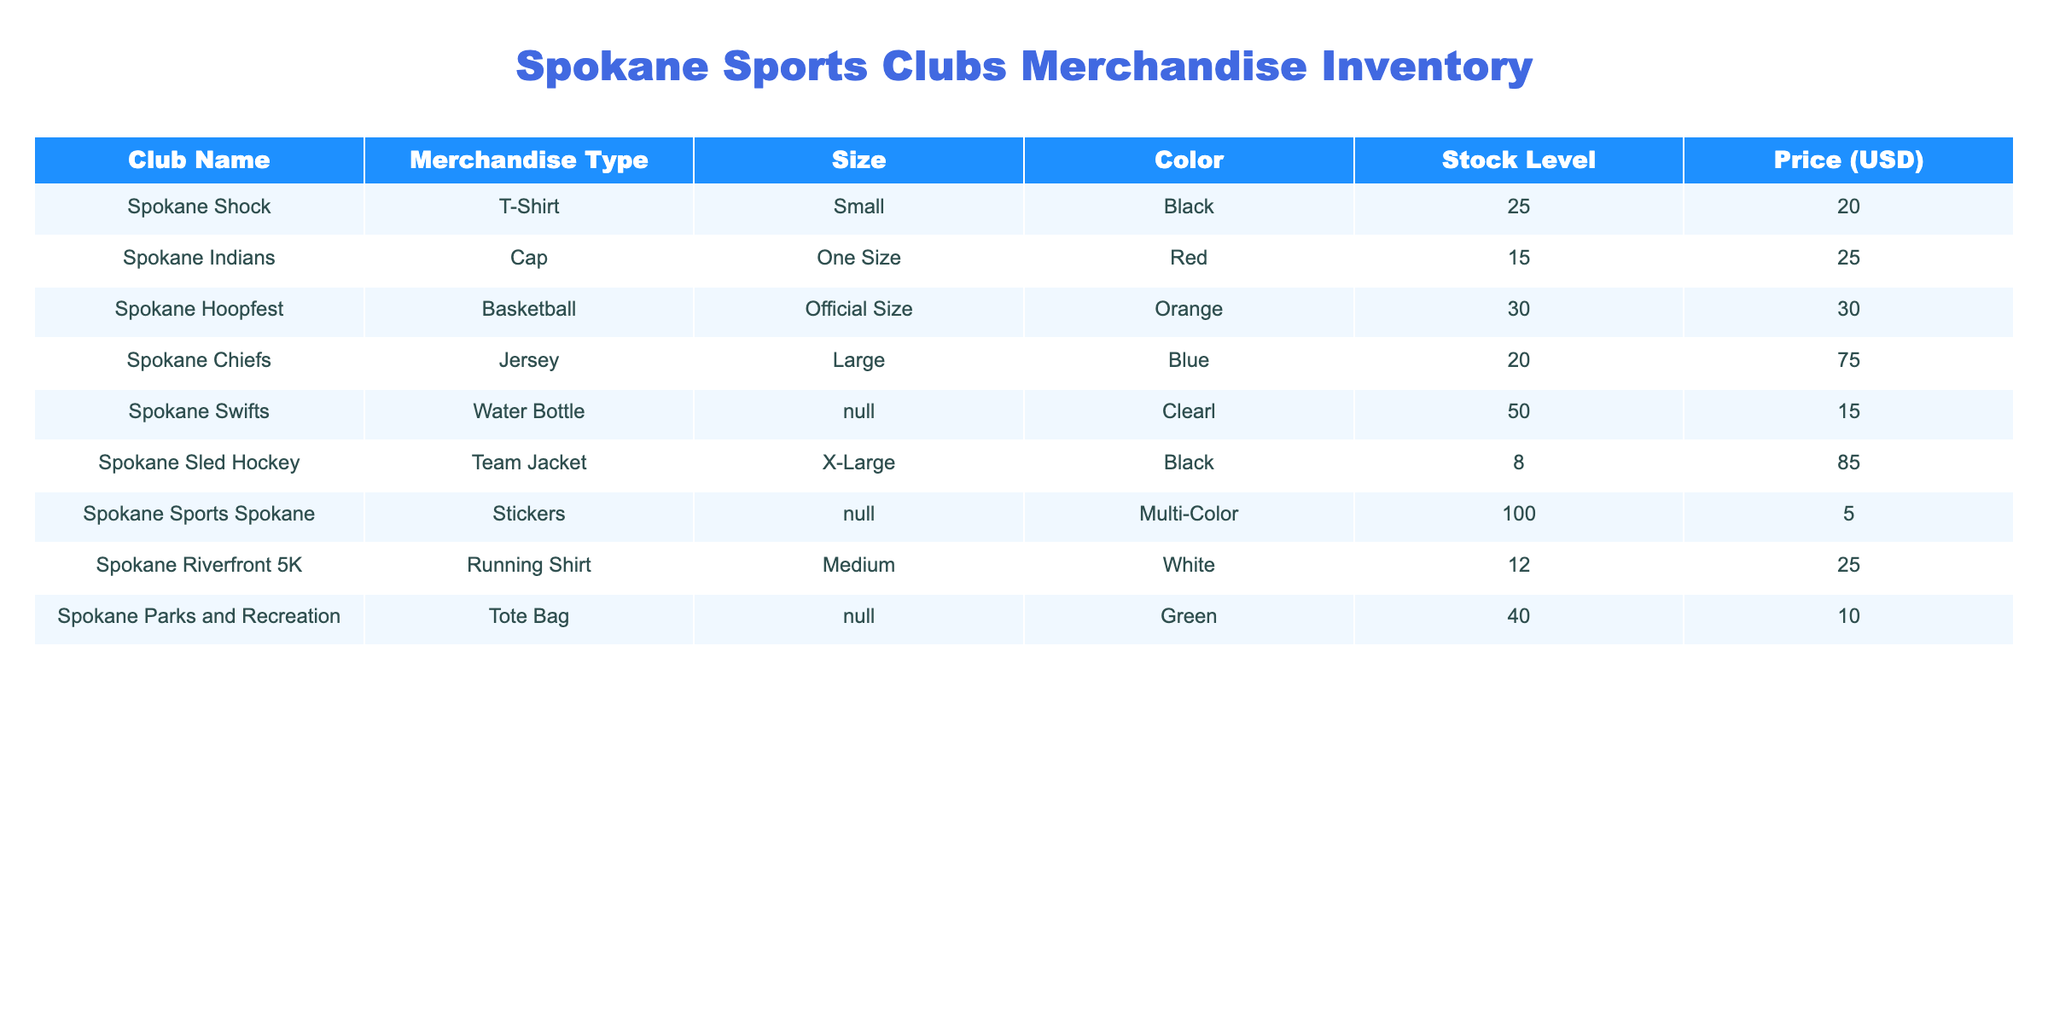What is the stock level of Spokane Shock T-Shirts? The table lists the merchandise inventory, and under the Spokane Shock row, the stock level is indicated as 25.
Answer: 25 How many items of stock are available for Spokane Chiefs Jerseys? The inventory for Spokane Chiefs Jerseys is listed as 20 units in the table.
Answer: 20 Which merchandise type has the highest stock level? By comparing the stock levels in the table, Spokane Sports Spokane has the highest stock level at 100.
Answer: Stickers Is there any merchandise that costs less than $15? Reviewing the price column, Spokane Sports Spokane Stickers at 5 USD is the only item priced below 15 USD.
Answer: Yes What is the total stock level of all merchandise types combined? Summing the stock levels (25 + 15 + 30 + 20 + 50 + 8 + 100 + 12 + 40) results in a total stock level of 300.
Answer: 300 Are there any items colored black in the inventory? Looking at the color column, the items colored black are Spokane Shock T-Shirt and Spokane Sled Hockey Team Jacket, meaning there are black items available.
Answer: Yes What is the average price of merchandise types in this inventory? To find the average price, we sum all prices (20 + 25 + 30 + 75 + 15 + 85 + 5 + 25 + 10 = 290), which gives us a total of 290, divided by 9 total items results in an average price of approximately 32.22.
Answer: 32.22 What is the total stock level of merchandise in orange color? The only orange merchandise listed is the Spokane Hoopfest Basketball with stock of 30, so the total in orange is 30 units.
Answer: 30 Which sports club has the most diverse range of merchandise types? Evaluating the table, Spokane Sports Spokane offers stickers which is different from others that focus on apparel or sports equipment, thus defining its diversity.
Answer: Spokane Sports Spokane 